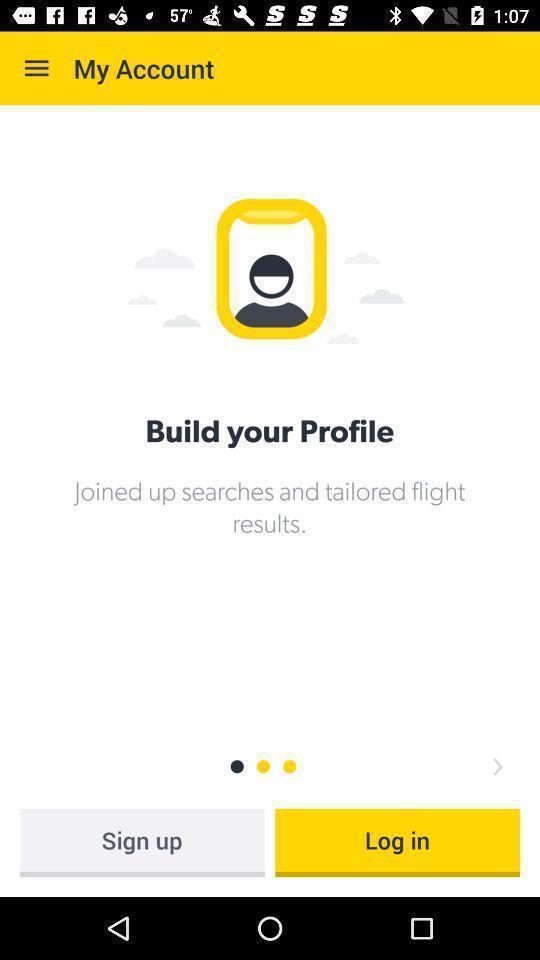Give me a narrative description of this picture. Welcome page. 